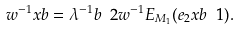<formula> <loc_0><loc_0><loc_500><loc_500>w ^ { - 1 } x b = \lambda ^ { - 1 } b \ 2 w ^ { - 1 } E _ { M _ { 1 } } ( e _ { 2 } x b \ 1 ) .</formula> 